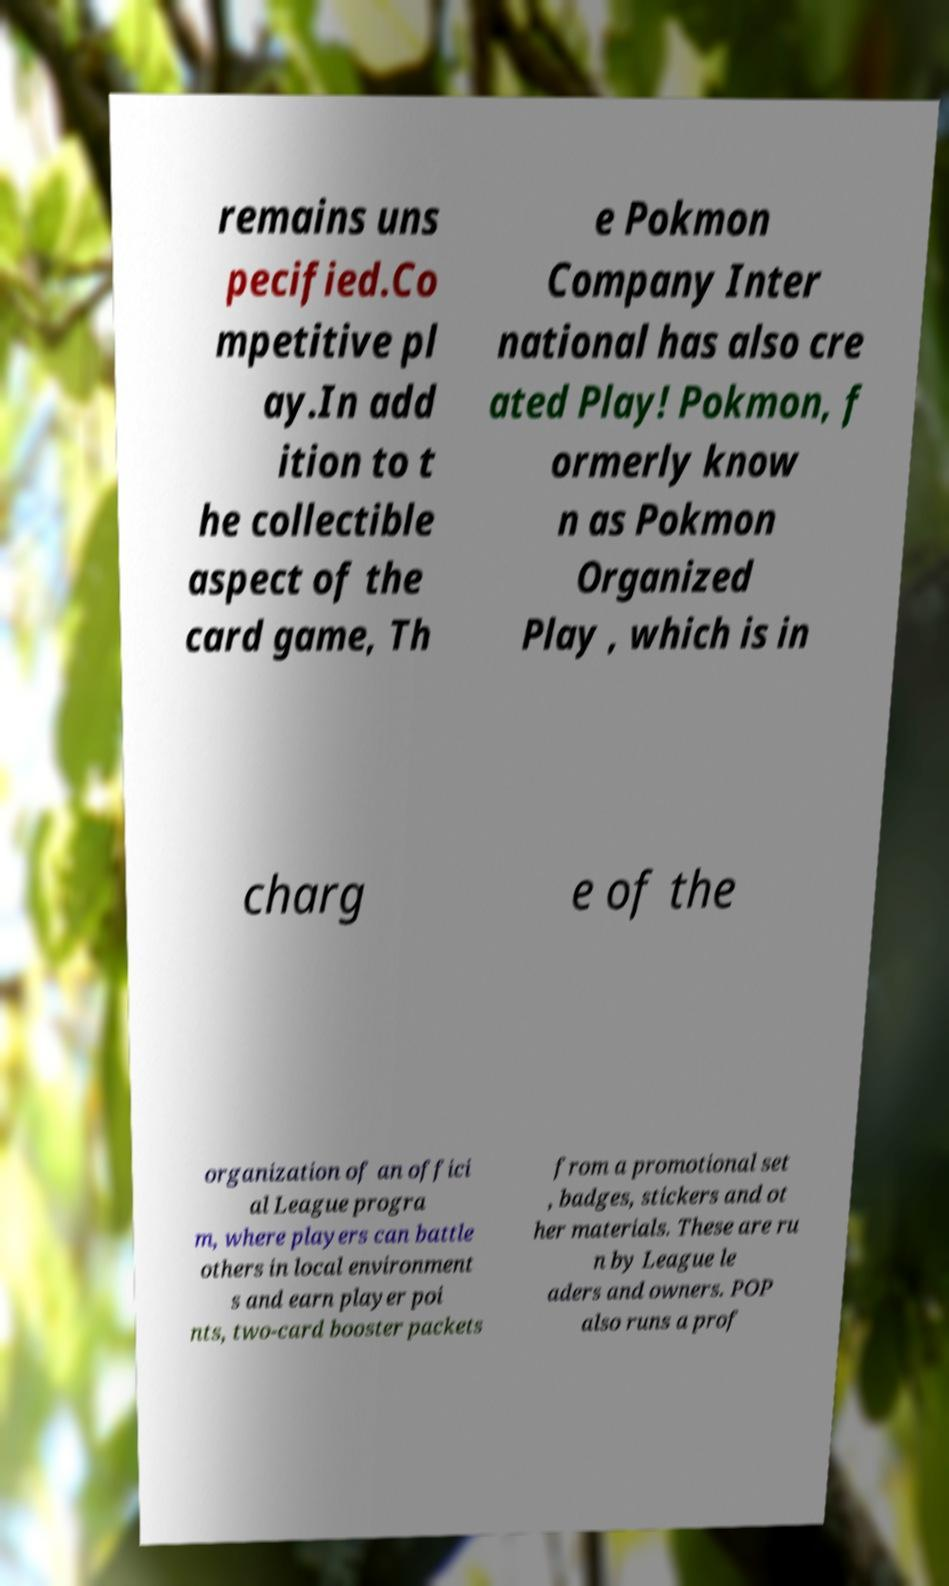What messages or text are displayed in this image? I need them in a readable, typed format. remains uns pecified.Co mpetitive pl ay.In add ition to t he collectible aspect of the card game, Th e Pokmon Company Inter national has also cre ated Play! Pokmon, f ormerly know n as Pokmon Organized Play , which is in charg e of the organization of an offici al League progra m, where players can battle others in local environment s and earn player poi nts, two-card booster packets from a promotional set , badges, stickers and ot her materials. These are ru n by League le aders and owners. POP also runs a prof 